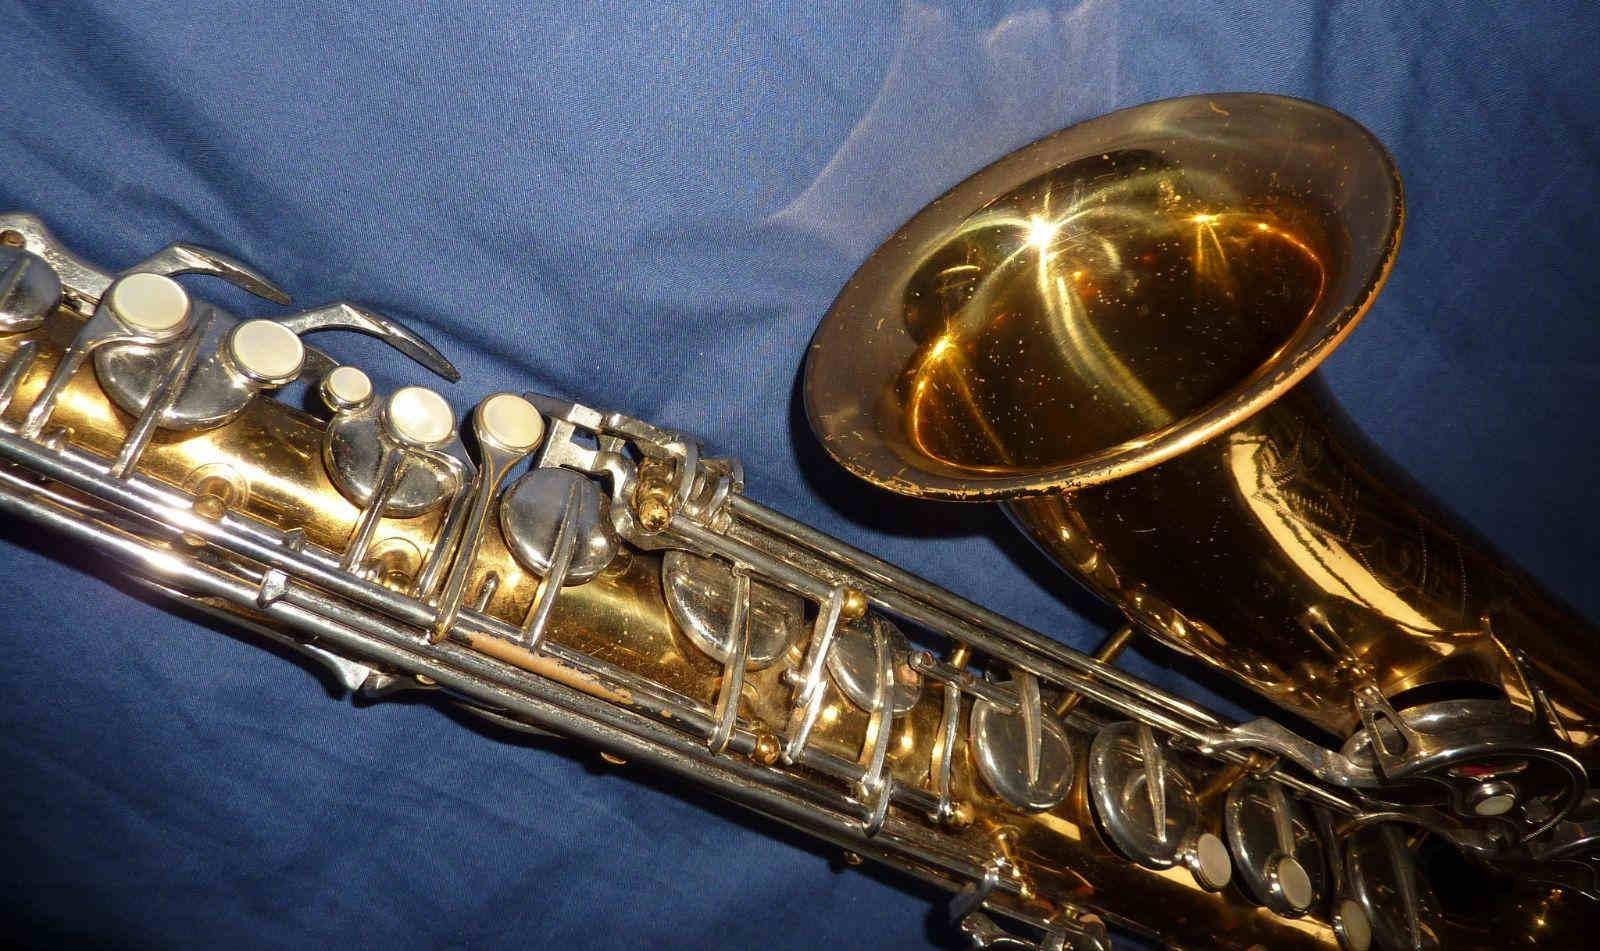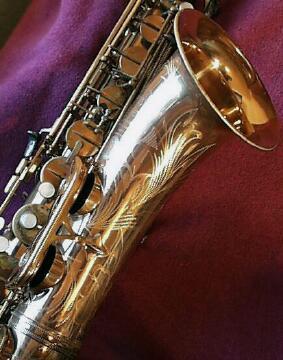The first image is the image on the left, the second image is the image on the right. Given the left and right images, does the statement "One image shows the etched bell of a gold saxophone, which is displayed on burgundy fabric." hold true? Answer yes or no. Yes. 